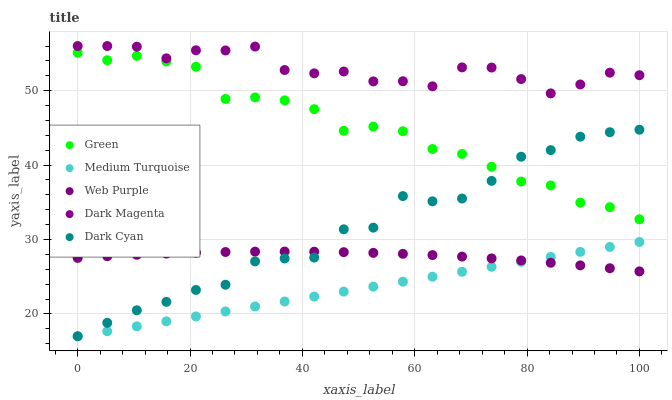Does Medium Turquoise have the minimum area under the curve?
Answer yes or no. Yes. Does Dark Magenta have the maximum area under the curve?
Answer yes or no. Yes. Does Web Purple have the minimum area under the curve?
Answer yes or no. No. Does Web Purple have the maximum area under the curve?
Answer yes or no. No. Is Medium Turquoise the smoothest?
Answer yes or no. Yes. Is Dark Cyan the roughest?
Answer yes or no. Yes. Is Web Purple the smoothest?
Answer yes or no. No. Is Web Purple the roughest?
Answer yes or no. No. Does Dark Cyan have the lowest value?
Answer yes or no. Yes. Does Web Purple have the lowest value?
Answer yes or no. No. Does Dark Magenta have the highest value?
Answer yes or no. Yes. Does Green have the highest value?
Answer yes or no. No. Is Medium Turquoise less than Green?
Answer yes or no. Yes. Is Dark Magenta greater than Dark Cyan?
Answer yes or no. Yes. Does Medium Turquoise intersect Web Purple?
Answer yes or no. Yes. Is Medium Turquoise less than Web Purple?
Answer yes or no. No. Is Medium Turquoise greater than Web Purple?
Answer yes or no. No. Does Medium Turquoise intersect Green?
Answer yes or no. No. 